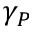Convert formula to latex. <formula><loc_0><loc_0><loc_500><loc_500>\gamma _ { P }</formula> 